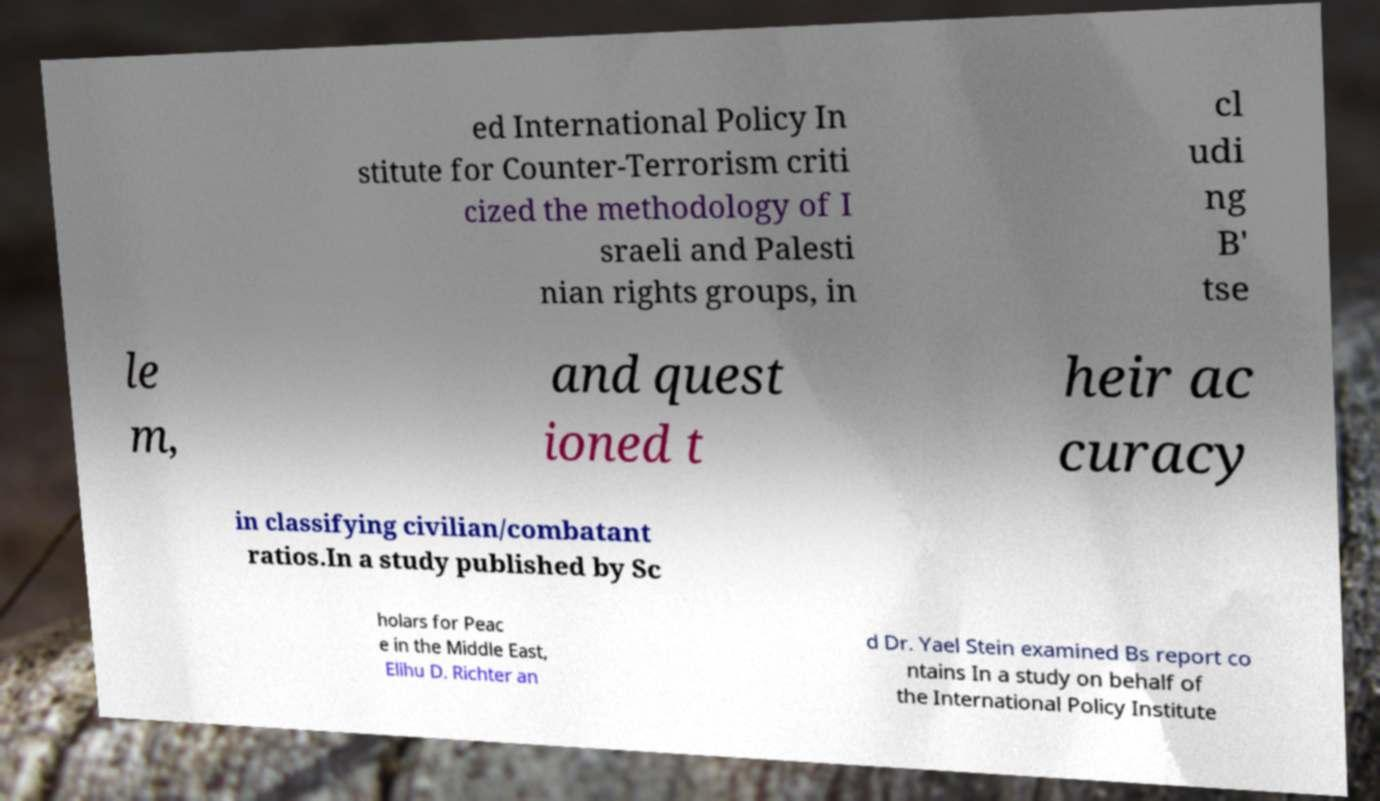Could you assist in decoding the text presented in this image and type it out clearly? ed International Policy In stitute for Counter-Terrorism criti cized the methodology of I sraeli and Palesti nian rights groups, in cl udi ng B' tse le m, and quest ioned t heir ac curacy in classifying civilian/combatant ratios.In a study published by Sc holars for Peac e in the Middle East, Elihu D. Richter an d Dr. Yael Stein examined Bs report co ntains In a study on behalf of the International Policy Institute 